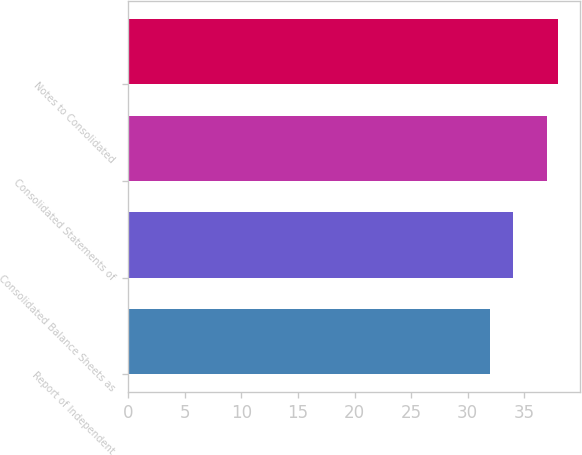Convert chart to OTSL. <chart><loc_0><loc_0><loc_500><loc_500><bar_chart><fcel>Report of Independent<fcel>Consolidated Balance Sheets as<fcel>Consolidated Statements of<fcel>Notes to Consolidated<nl><fcel>32<fcel>34<fcel>37<fcel>38<nl></chart> 